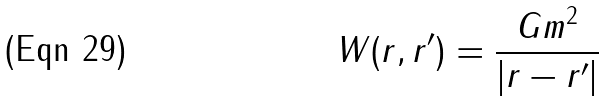Convert formula to latex. <formula><loc_0><loc_0><loc_500><loc_500>W ( r , r ^ { \prime } ) = \frac { G m ^ { 2 } } { | r - r ^ { \prime } | }</formula> 